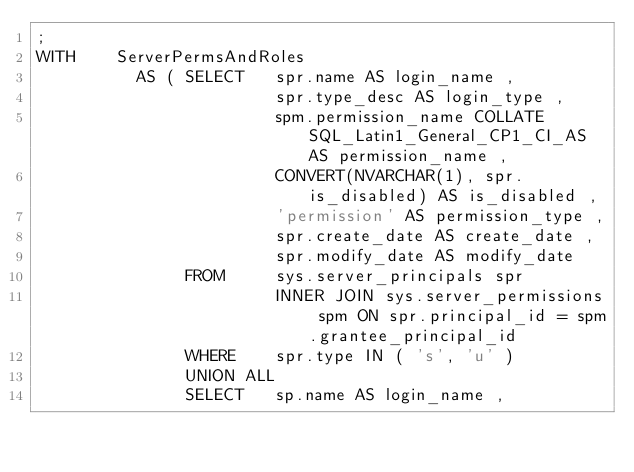<code> <loc_0><loc_0><loc_500><loc_500><_SQL_>;
WITH    ServerPermsAndRoles
          AS ( SELECT   spr.name AS login_name ,
                        spr.type_desc AS login_type ,
                        spm.permission_name COLLATE SQL_Latin1_General_CP1_CI_AS AS permission_name ,
                        CONVERT(NVARCHAR(1), spr.is_disabled) AS is_disabled ,
                        'permission' AS permission_type ,
                        spr.create_date AS create_date ,
                        spr.modify_date AS modify_date
               FROM     sys.server_principals spr
                        INNER JOIN sys.server_permissions spm ON spr.principal_id = spm.grantee_principal_id
               WHERE    spr.type IN ( 's', 'u' )
               UNION ALL
               SELECT   sp.name AS login_name ,</code> 